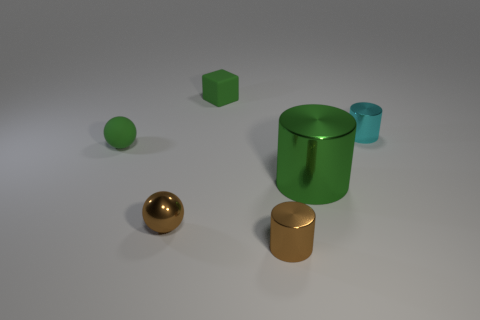Subtract all brown cylinders. How many cylinders are left? 2 Add 1 tiny green cubes. How many objects exist? 7 Subtract all green cylinders. How many cylinders are left? 2 Subtract all blocks. How many objects are left? 5 Subtract 2 cylinders. How many cylinders are left? 1 Subtract all tiny green cylinders. Subtract all large things. How many objects are left? 5 Add 5 green balls. How many green balls are left? 6 Add 2 small green things. How many small green things exist? 4 Subtract 0 yellow cubes. How many objects are left? 6 Subtract all brown balls. Subtract all blue cylinders. How many balls are left? 1 